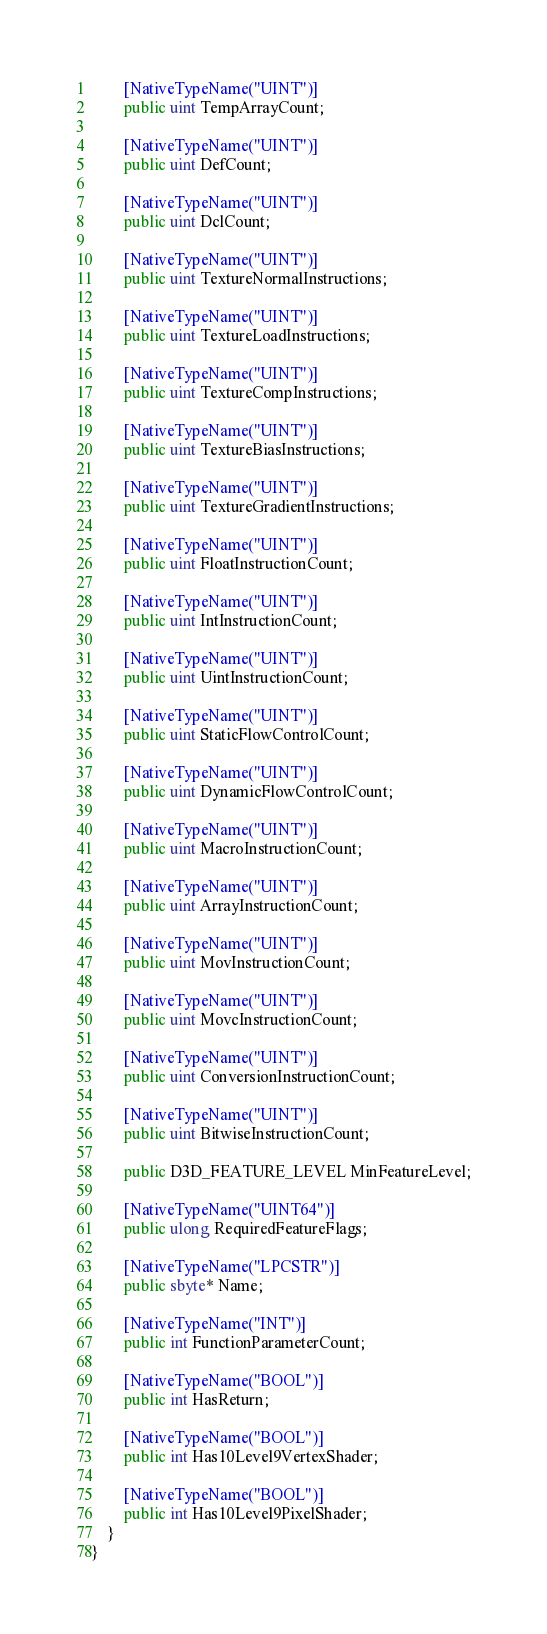<code> <loc_0><loc_0><loc_500><loc_500><_C#_>        [NativeTypeName("UINT")]
        public uint TempArrayCount;

        [NativeTypeName("UINT")]
        public uint DefCount;

        [NativeTypeName("UINT")]
        public uint DclCount;

        [NativeTypeName("UINT")]
        public uint TextureNormalInstructions;

        [NativeTypeName("UINT")]
        public uint TextureLoadInstructions;

        [NativeTypeName("UINT")]
        public uint TextureCompInstructions;

        [NativeTypeName("UINT")]
        public uint TextureBiasInstructions;

        [NativeTypeName("UINT")]
        public uint TextureGradientInstructions;

        [NativeTypeName("UINT")]
        public uint FloatInstructionCount;

        [NativeTypeName("UINT")]
        public uint IntInstructionCount;

        [NativeTypeName("UINT")]
        public uint UintInstructionCount;

        [NativeTypeName("UINT")]
        public uint StaticFlowControlCount;

        [NativeTypeName("UINT")]
        public uint DynamicFlowControlCount;

        [NativeTypeName("UINT")]
        public uint MacroInstructionCount;

        [NativeTypeName("UINT")]
        public uint ArrayInstructionCount;

        [NativeTypeName("UINT")]
        public uint MovInstructionCount;

        [NativeTypeName("UINT")]
        public uint MovcInstructionCount;

        [NativeTypeName("UINT")]
        public uint ConversionInstructionCount;

        [NativeTypeName("UINT")]
        public uint BitwiseInstructionCount;

        public D3D_FEATURE_LEVEL MinFeatureLevel;

        [NativeTypeName("UINT64")]
        public ulong RequiredFeatureFlags;

        [NativeTypeName("LPCSTR")]
        public sbyte* Name;

        [NativeTypeName("INT")]
        public int FunctionParameterCount;

        [NativeTypeName("BOOL")]
        public int HasReturn;

        [NativeTypeName("BOOL")]
        public int Has10Level9VertexShader;

        [NativeTypeName("BOOL")]
        public int Has10Level9PixelShader;
    }
}
</code> 